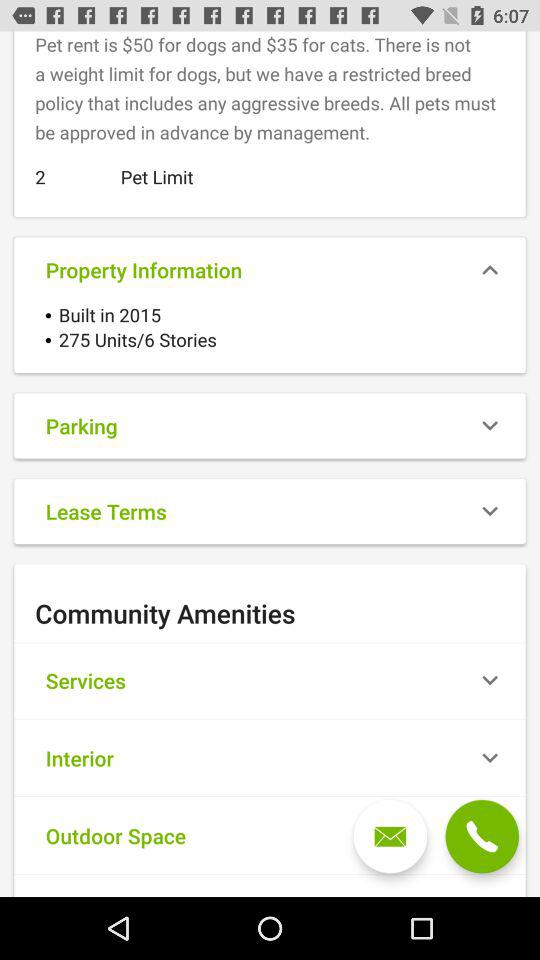Is there a weight limit for dogs? There is no weight limit for dogs. 